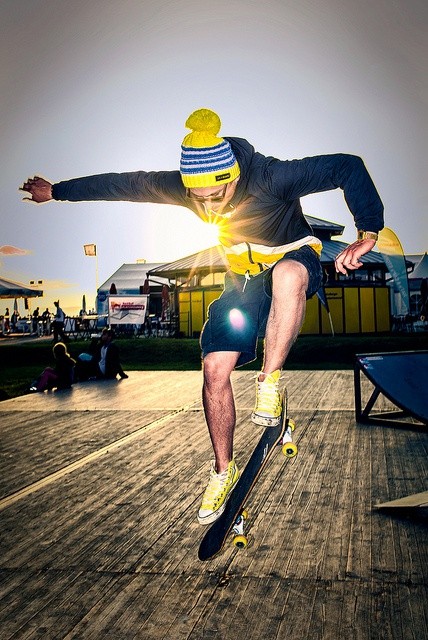Describe the objects in this image and their specific colors. I can see people in gray, black, navy, white, and salmon tones, skateboard in gray, black, and tan tones, people in gray, black, navy, and blue tones, people in gray, black, olive, and maroon tones, and people in gray, black, navy, and blue tones in this image. 